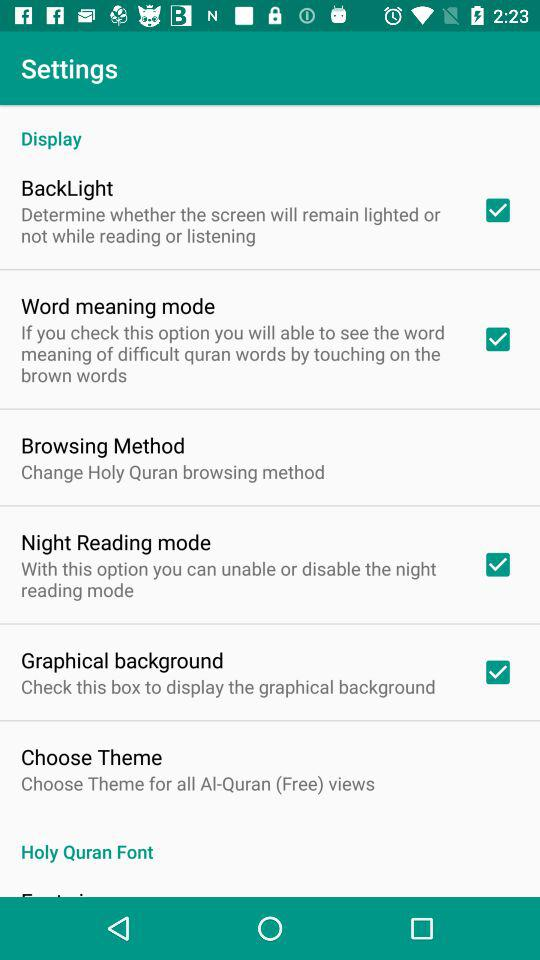What is the name of the checked setting option? The names of the checked setting options are "BackLight", "Word meaning mode", "Night Reading mode" and "Graphical background". 